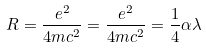<formula> <loc_0><loc_0><loc_500><loc_500>R = \frac { e ^ { 2 } } { 4 m c ^ { 2 } } = \frac { e ^ { 2 } } { 4 m c ^ { 2 } } = \frac { 1 } { 4 } \alpha \lambda</formula> 